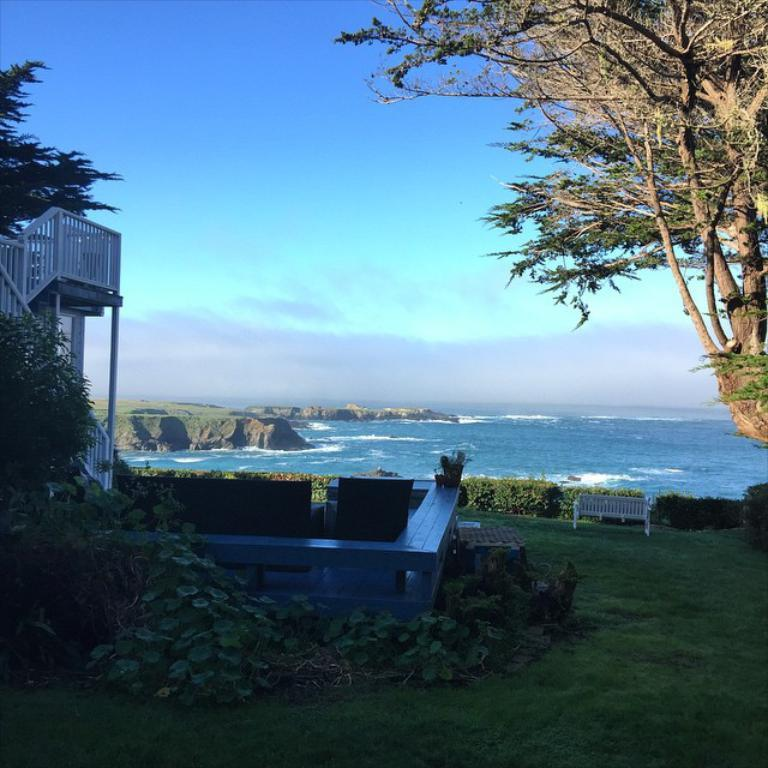What type of terrain is visible in the image? There is grassy land in the image. What types of vegetation can be seen in the image? There are plants, trees, and grass visible in the image. What type of seating is present in the image? There are benches and a chair in the image. What other structures can be seen in the image? There is a railing and a pole in the image. What can be seen in the distance in the image? There is sea visible in the image. How would you describe the sky in the image? The sky is blue with clouds. What type of bulb is used to light up the quince in the image? There is no bulb or quince present in the image. 